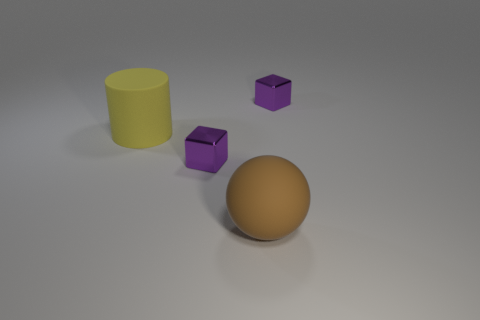Could you describe the lighting and shadows visible in the image? The lighting in the image appears to be coming from above, casting soft shadows on the ground to the right of the objects. This creates a slightly dramatic effect while still maintaining a clear view of the objects' shapes and colors. 